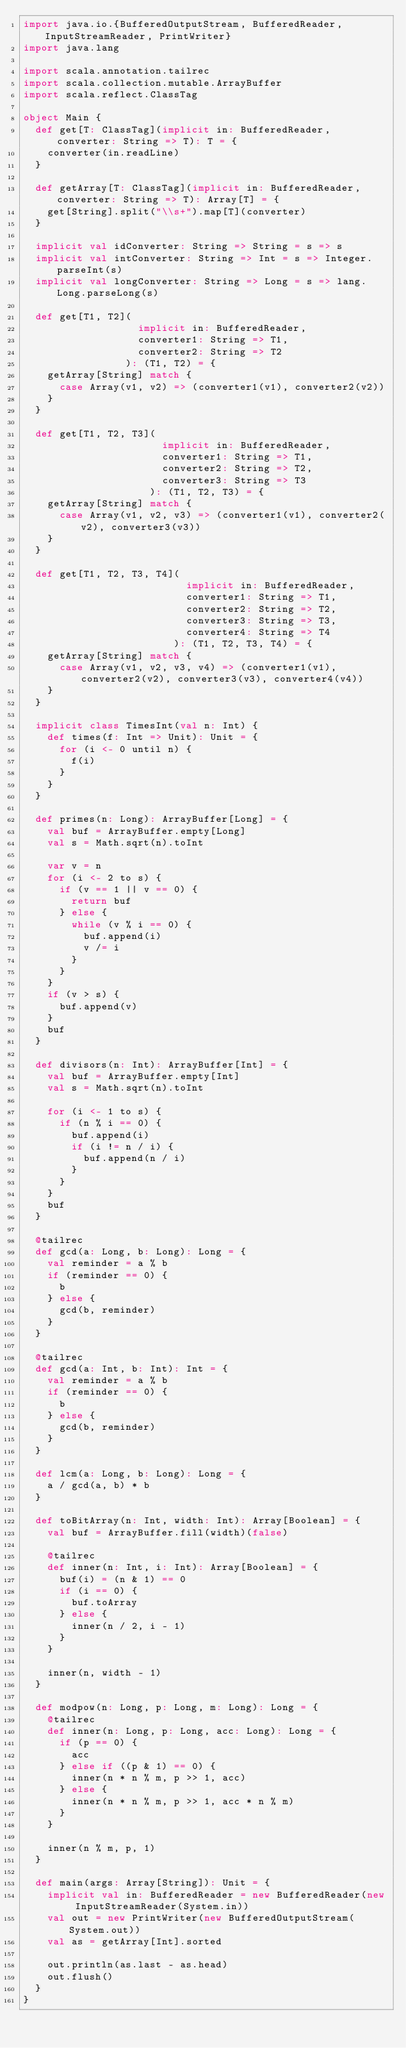Convert code to text. <code><loc_0><loc_0><loc_500><loc_500><_Scala_>import java.io.{BufferedOutputStream, BufferedReader, InputStreamReader, PrintWriter}
import java.lang

import scala.annotation.tailrec
import scala.collection.mutable.ArrayBuffer
import scala.reflect.ClassTag

object Main {
  def get[T: ClassTag](implicit in: BufferedReader, converter: String => T): T = {
    converter(in.readLine)
  }

  def getArray[T: ClassTag](implicit in: BufferedReader, converter: String => T): Array[T] = {
    get[String].split("\\s+").map[T](converter)
  }

  implicit val idConverter: String => String = s => s
  implicit val intConverter: String => Int = s => Integer.parseInt(s)
  implicit val longConverter: String => Long = s => lang.Long.parseLong(s)

  def get[T1, T2](
                   implicit in: BufferedReader,
                   converter1: String => T1,
                   converter2: String => T2
                 ): (T1, T2) = {
    getArray[String] match {
      case Array(v1, v2) => (converter1(v1), converter2(v2))
    }
  }

  def get[T1, T2, T3](
                       implicit in: BufferedReader,
                       converter1: String => T1,
                       converter2: String => T2,
                       converter3: String => T3
                     ): (T1, T2, T3) = {
    getArray[String] match {
      case Array(v1, v2, v3) => (converter1(v1), converter2(v2), converter3(v3))
    }
  }

  def get[T1, T2, T3, T4](
                           implicit in: BufferedReader,
                           converter1: String => T1,
                           converter2: String => T2,
                           converter3: String => T3,
                           converter4: String => T4
                         ): (T1, T2, T3, T4) = {
    getArray[String] match {
      case Array(v1, v2, v3, v4) => (converter1(v1), converter2(v2), converter3(v3), converter4(v4))
    }
  }

  implicit class TimesInt(val n: Int) {
    def times(f: Int => Unit): Unit = {
      for (i <- 0 until n) {
        f(i)
      }
    }
  }

  def primes(n: Long): ArrayBuffer[Long] = {
    val buf = ArrayBuffer.empty[Long]
    val s = Math.sqrt(n).toInt

    var v = n
    for (i <- 2 to s) {
      if (v == 1 || v == 0) {
        return buf
      } else {
        while (v % i == 0) {
          buf.append(i)
          v /= i
        }
      }
    }
    if (v > s) {
      buf.append(v)
    }
    buf
  }

  def divisors(n: Int): ArrayBuffer[Int] = {
    val buf = ArrayBuffer.empty[Int]
    val s = Math.sqrt(n).toInt

    for (i <- 1 to s) {
      if (n % i == 0) {
        buf.append(i)
        if (i != n / i) {
          buf.append(n / i)
        }
      }
    }
    buf
  }

  @tailrec
  def gcd(a: Long, b: Long): Long = {
    val reminder = a % b
    if (reminder == 0) {
      b
    } else {
      gcd(b, reminder)
    }
  }

  @tailrec
  def gcd(a: Int, b: Int): Int = {
    val reminder = a % b
    if (reminder == 0) {
      b
    } else {
      gcd(b, reminder)
    }
  }

  def lcm(a: Long, b: Long): Long = {
    a / gcd(a, b) * b
  }

  def toBitArray(n: Int, width: Int): Array[Boolean] = {
    val buf = ArrayBuffer.fill(width)(false)

    @tailrec
    def inner(n: Int, i: Int): Array[Boolean] = {
      buf(i) = (n & 1) == 0
      if (i == 0) {
        buf.toArray
      } else {
        inner(n / 2, i - 1)
      }
    }

    inner(n, width - 1)
  }

  def modpow(n: Long, p: Long, m: Long): Long = {
    @tailrec
    def inner(n: Long, p: Long, acc: Long): Long = {
      if (p == 0) {
        acc
      } else if ((p & 1) == 0) {
        inner(n * n % m, p >> 1, acc)
      } else {
        inner(n * n % m, p >> 1, acc * n % m)
      }
    }

    inner(n % m, p, 1)
  }

  def main(args: Array[String]): Unit = {
    implicit val in: BufferedReader = new BufferedReader(new InputStreamReader(System.in))
    val out = new PrintWriter(new BufferedOutputStream(System.out))
    val as = getArray[Int].sorted

    out.println(as.last - as.head)
    out.flush()
  }
}</code> 